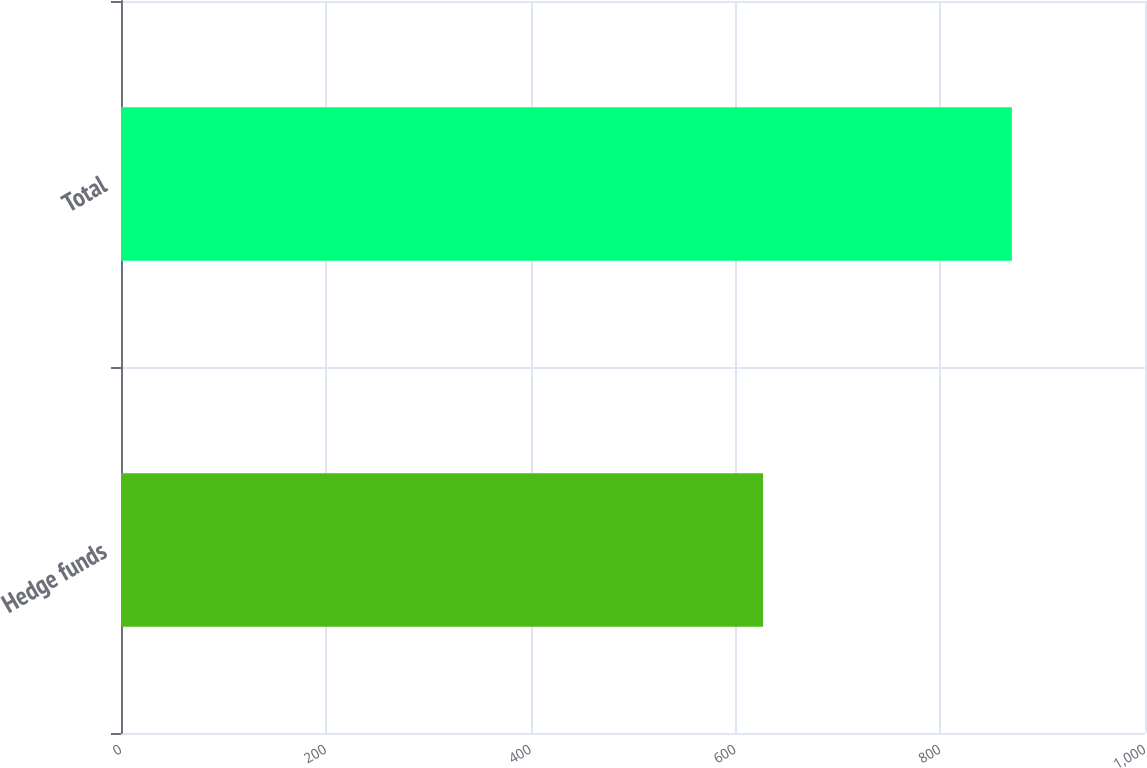Convert chart. <chart><loc_0><loc_0><loc_500><loc_500><bar_chart><fcel>Hedge funds<fcel>Total<nl><fcel>627<fcel>870<nl></chart> 